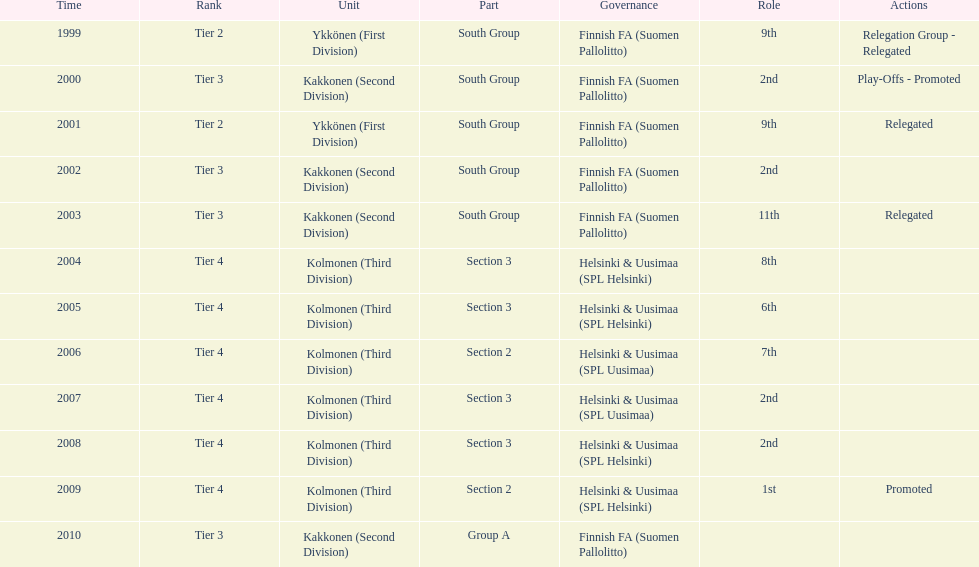How many times were they in tier 3? 4. 